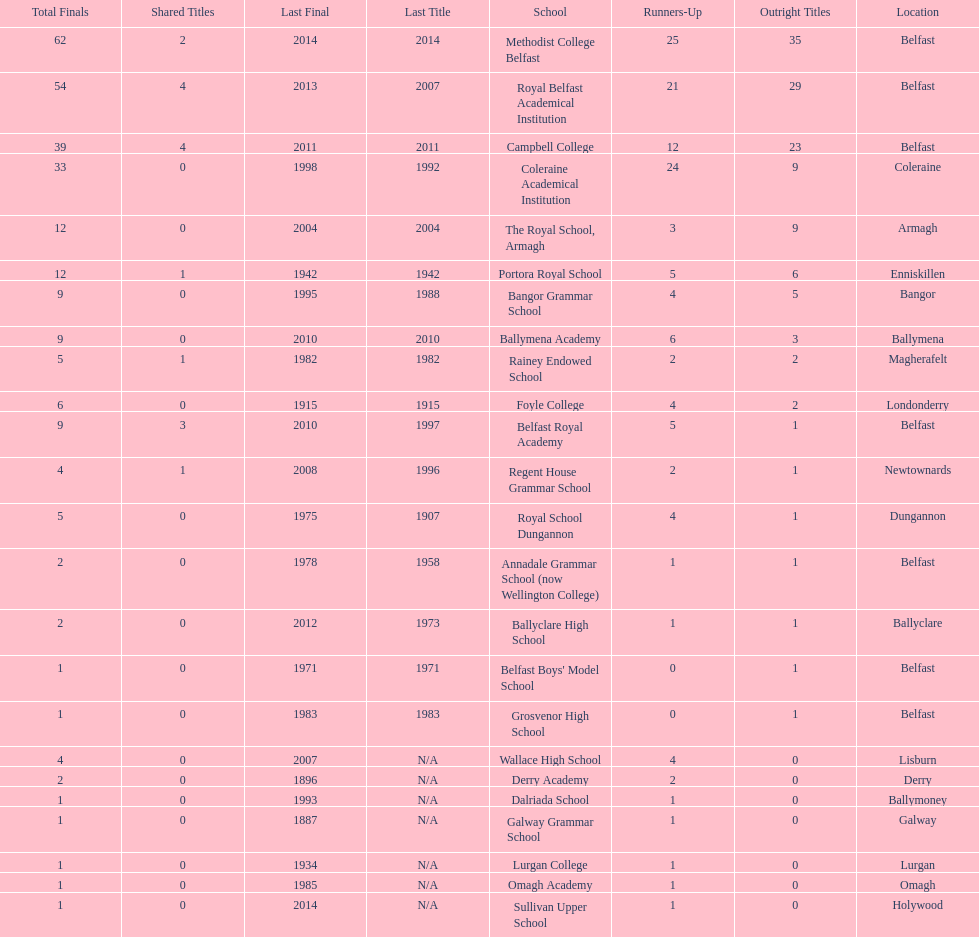Did belfast royal academy have more or less total finals than ballyclare high school? More. 